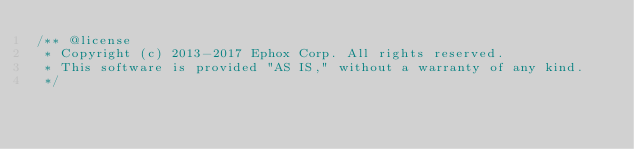Convert code to text. <code><loc_0><loc_0><loc_500><loc_500><_JavaScript_>/** @license
 * Copyright (c) 2013-2017 Ephox Corp. All rights reserved.
 * This software is provided "AS IS," without a warranty of any kind.
 */</code> 